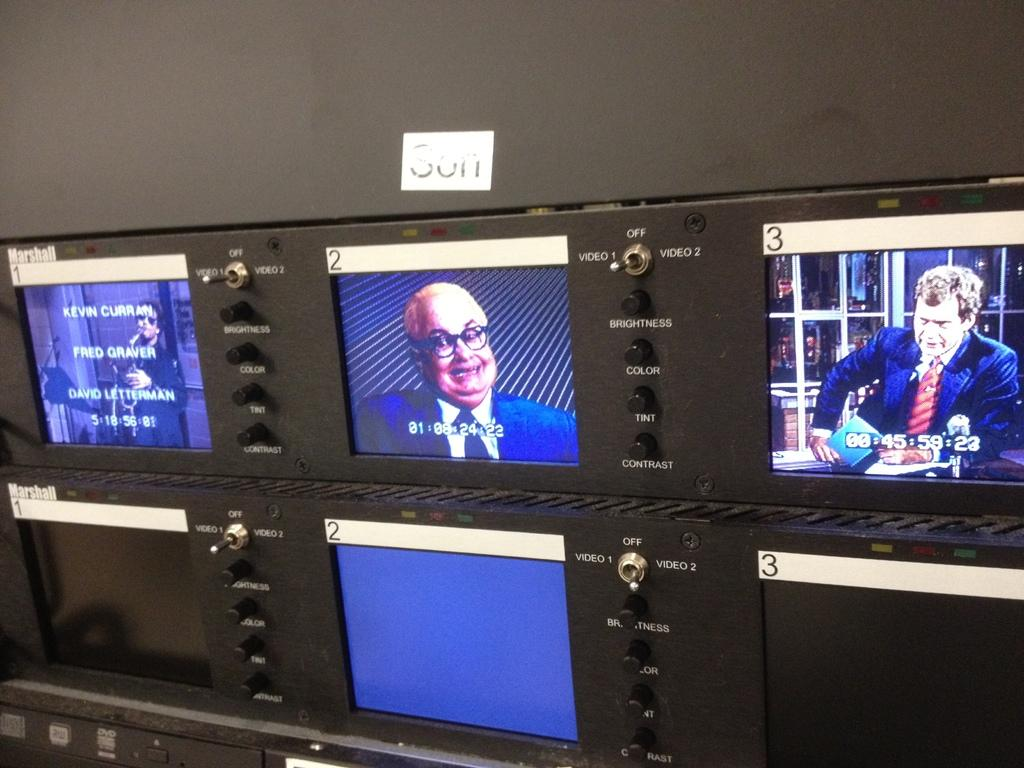<image>
Share a concise interpretation of the image provided. A Marshall panel of monitors play shots of a TV show. 